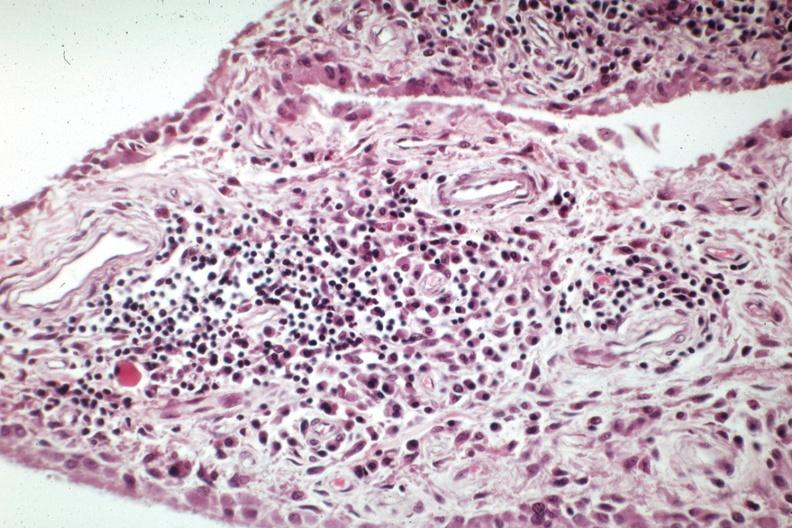what is present?
Answer the question using a single word or phrase. Joints 